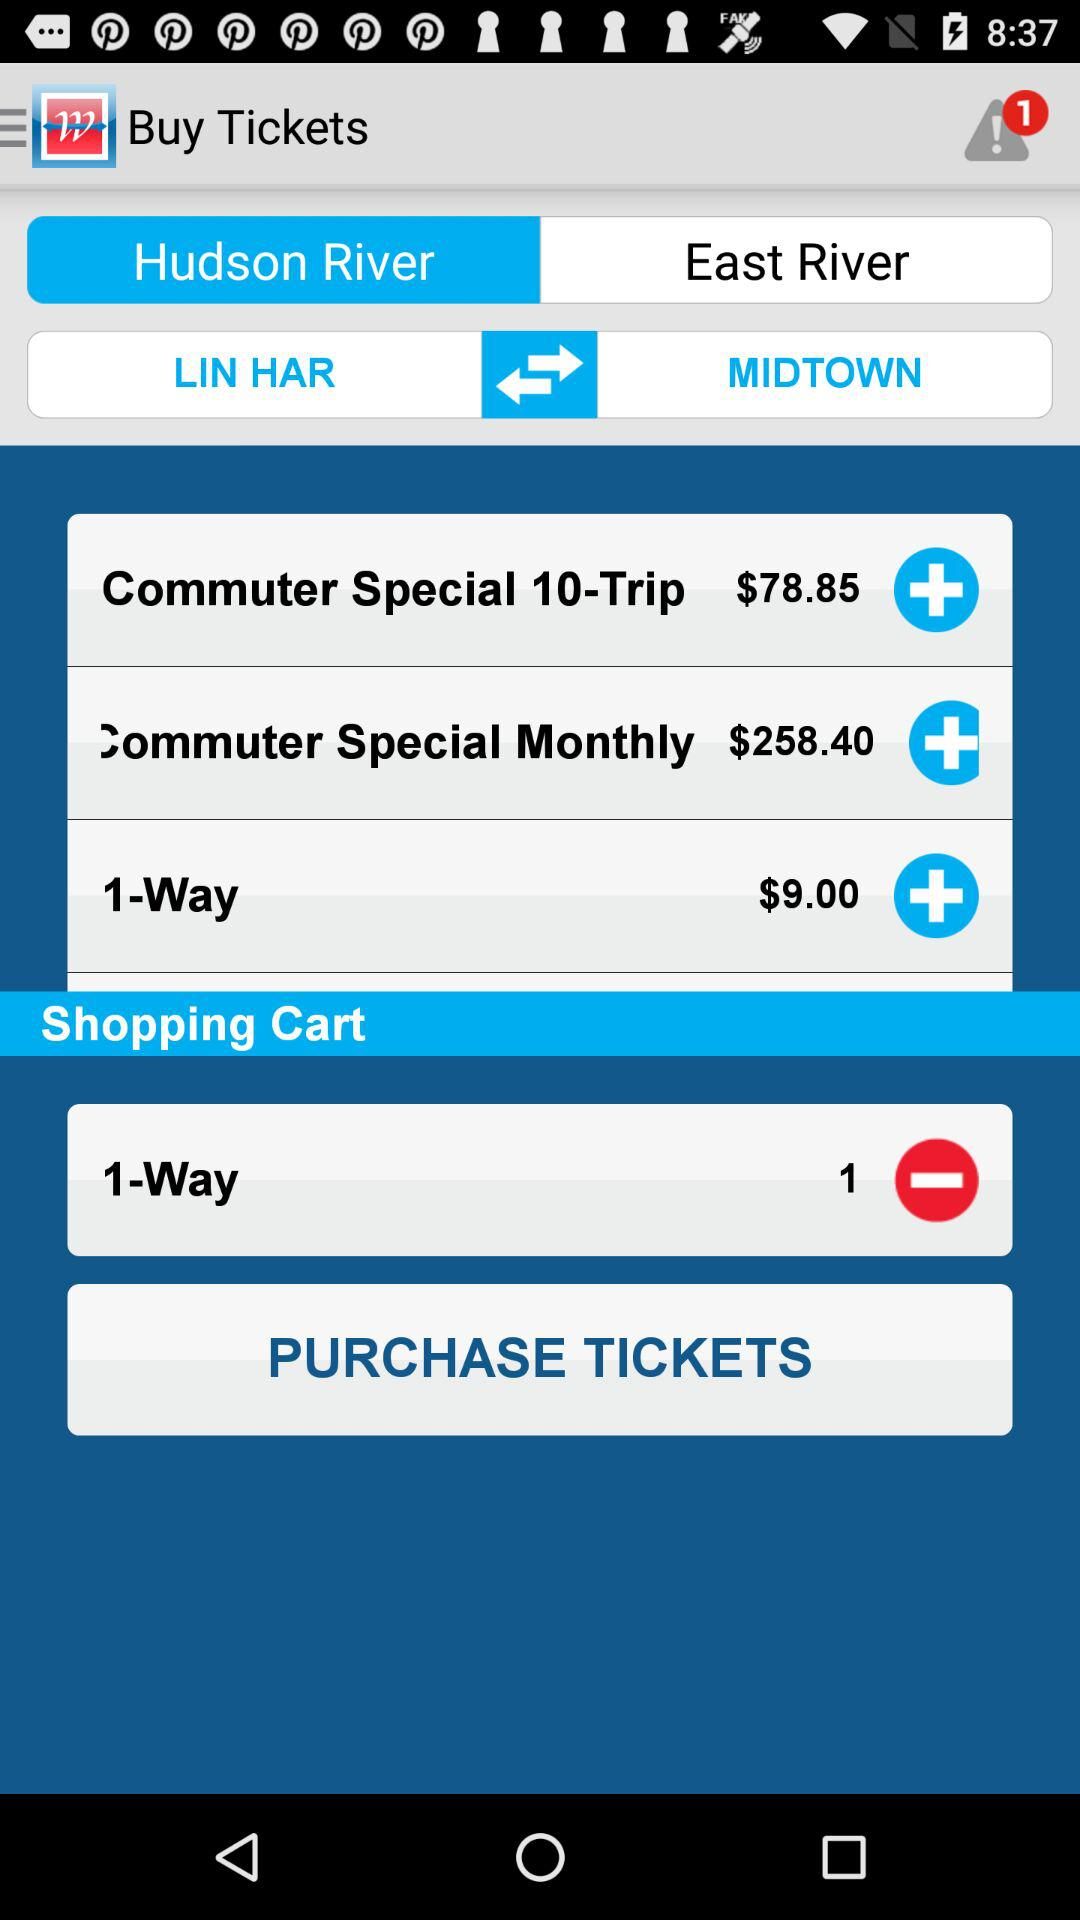What is the fare for one way? The fare for one way is $9. 